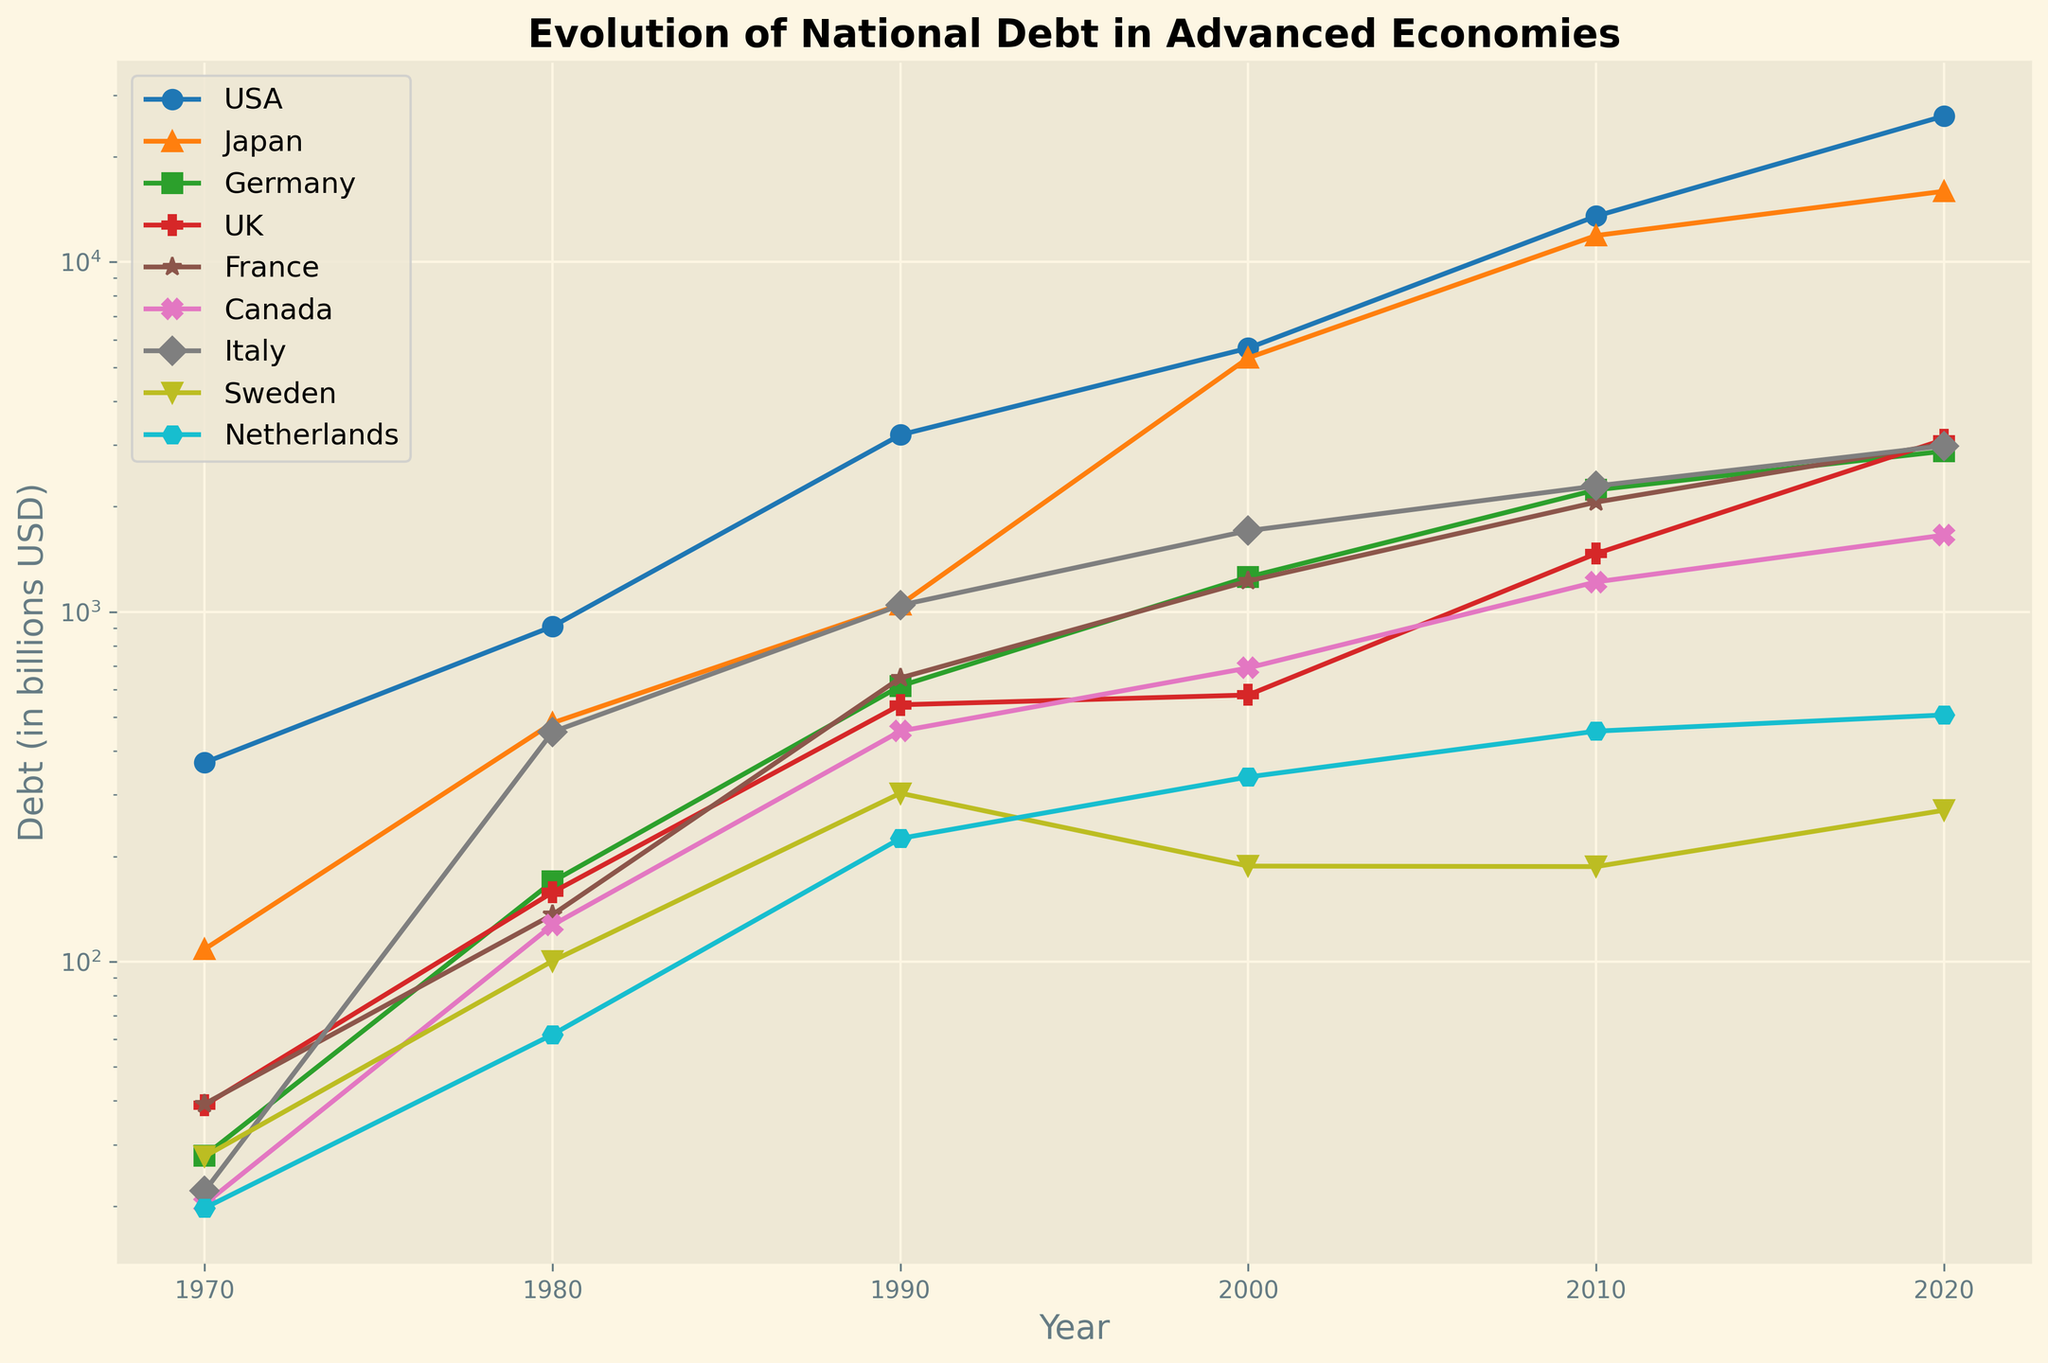What's the highest national debt recorded in the figure? First, identify the highest point on the y-axis in the plot. The USA in 2020 has the highest value, with a debt of 26149.178 billion USD.
Answer: 26149.178 billion USD Which country has the smallest national debt in 2020, and what's the value? Look at the end points for each country in 2020 and compare their debt values. Sweden has the smallest debt in 2020, which is 270.843 billion USD.
Answer: Sweden with 270.843 billion USD What country had the greatest increase in national debt from 1970 to 2020? Calculate the difference for each country between their 2020 and 1970 values. USA's increase is 26149.178 - 370.919 = 25778.259 billion USD, which is the largest increase.
Answer: USA Between Japan and Germany, which country showed a higher percentage increase in debt from 1970 to 2020? Calculate the percentage increase for both countries: 
- Japan: ((15935.763 - 108.635) / 108.635) * 100 ≈ 14590%
- Germany: ((2879.496 - 27.876) / 27.876) * 100 ≈ 10232%
Japan has a higher percentage increase.
Answer: Japan In which decade did France see the largest absolute increase in its national debt? Calculate the absolute increase for each decade for France:
- 1970-1980: 136.273 - 39.227 = 97.046
- 1980-1990: 647.324 - 136.273 = 511.051
- 1990-2000: 1224.677 - 647.324 = 577.353
- 2000-2010: 2058.622 - 1224.677 = 833.945
- 2010-2020: 3020.645 - 2058.622 = 962.023
The largest increase was in the 2010s.
Answer: 2010s Which country has the steepest increase in debt between 2010 and 2020 and how can you tell? Observe the gradient of the lines between 2010 and 2020. The USA shows the steepest increase. Look at the slope and significant rise in the vertical position of USA's line compared to others.
Answer: USA For Canada, what's the average annual increase in national debt from 1980 to 2000? Calculate the increase between 1980 and 2000, then divide by the number of years: (691.402 - 127.257) / (2000 - 1980) = 564.145 / 20 = 28.207 billion USD per year.
Answer: 28.207 billion USD Which country exhibited the most stable debt levels between 2010 and 2020 based on the visual trend? Identify the country with the least change in slope for the period 2010-2020. Sweden's line is relatively flat compared to other countries.
Answer: Sweden What is the difference in debt between the UK and Germany in 2020? Subtract Germany’s 2020 debt value from the UK’s 2020 value: 3107.670 - 2879.496 = 228.174 billion USD.
Answer: 228.174 billion USD Which country had more debt in 1980, Japan or Italy, and by how much? Compare the debt values of Japan and Italy in 1980: 481.497 (Japan) - 453.845 (Italy) = 27.652 billion USD. Japan had more debt.
Answer: Japan by 27.652 billion USD 